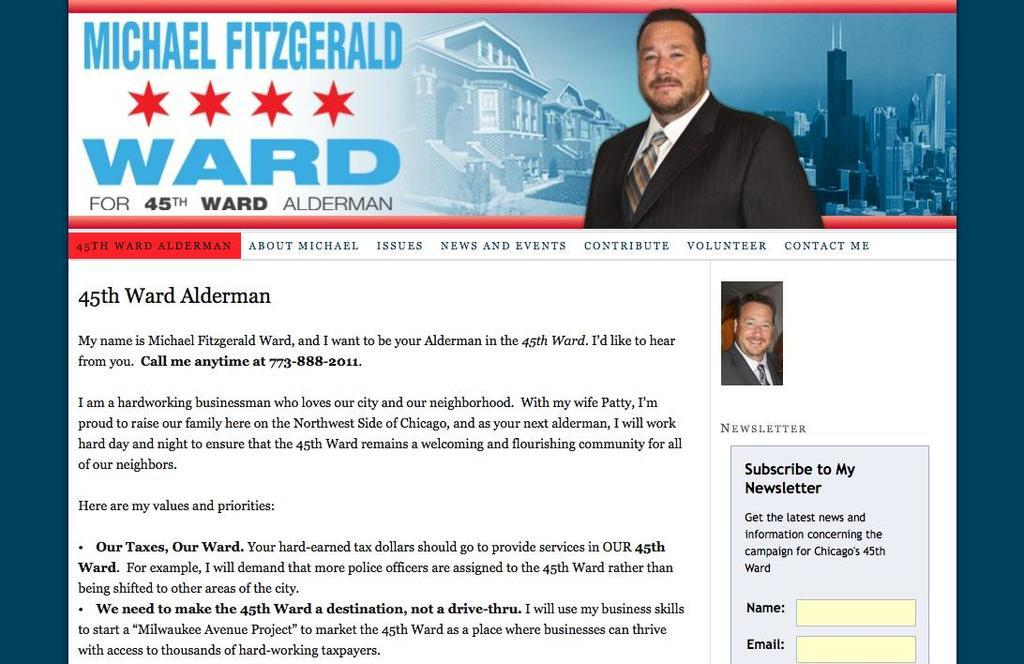What type of content is displayed in the image? The image contains a screenshot of a website. Can you describe the main image on the website? There is a picture of a person on the website. What can be seen in the background of the picture? There are buildings visible in the picture. Is there any text present on the website? Yes, there is text written on the picture. What type of oatmeal is being served in the picture? There is no oatmeal present in the image; it features a screenshot of a website with a picture of a person and text. Can you tell me how many cannons are visible in the picture? There are no cannons visible in the picture; it only contains a screenshot of a website with a picture of a person and text. 